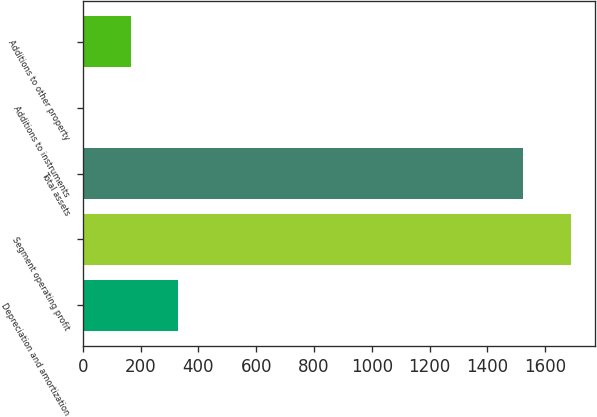Convert chart. <chart><loc_0><loc_0><loc_500><loc_500><bar_chart><fcel>Depreciation and amortization<fcel>Segment operating profit<fcel>Total assets<fcel>Additions to instruments<fcel>Additions to other property<nl><fcel>330.68<fcel>1689.54<fcel>1525<fcel>1.6<fcel>166.14<nl></chart> 